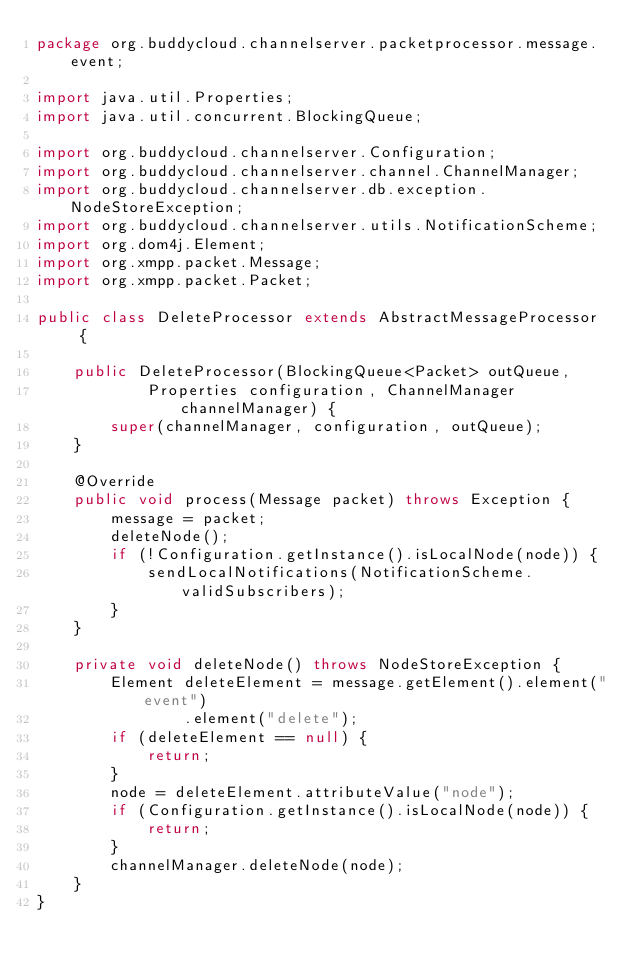Convert code to text. <code><loc_0><loc_0><loc_500><loc_500><_Java_>package org.buddycloud.channelserver.packetprocessor.message.event;

import java.util.Properties;
import java.util.concurrent.BlockingQueue;

import org.buddycloud.channelserver.Configuration;
import org.buddycloud.channelserver.channel.ChannelManager;
import org.buddycloud.channelserver.db.exception.NodeStoreException;
import org.buddycloud.channelserver.utils.NotificationScheme;
import org.dom4j.Element;
import org.xmpp.packet.Message;
import org.xmpp.packet.Packet;
 
public class DeleteProcessor extends AbstractMessageProcessor  {
 
    public DeleteProcessor(BlockingQueue<Packet> outQueue,
            Properties configuration, ChannelManager channelManager) {
        super(channelManager, configuration, outQueue);
    }

    @Override
    public void process(Message packet) throws Exception {
        message = packet;
        deleteNode();
        if (!Configuration.getInstance().isLocalNode(node)) {
            sendLocalNotifications(NotificationScheme.validSubscribers);
        }
    }

    private void deleteNode() throws NodeStoreException {
        Element deleteElement = message.getElement().element("event")
                .element("delete");
        if (deleteElement == null) {
            return;
        }
        node = deleteElement.attributeValue("node");
        if (Configuration.getInstance().isLocalNode(node)) {
            return;
        }
        channelManager.deleteNode(node);
    }
}
</code> 